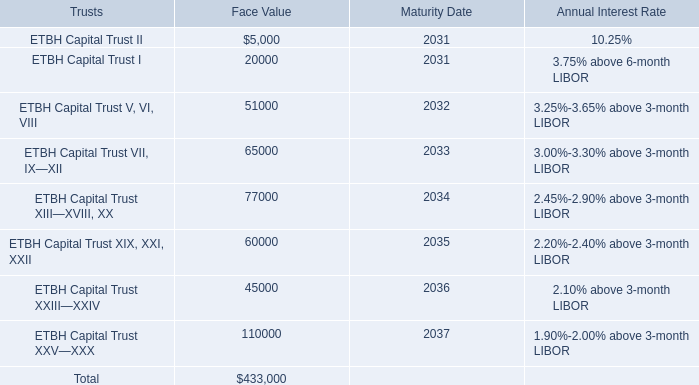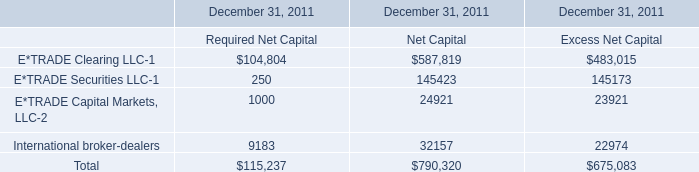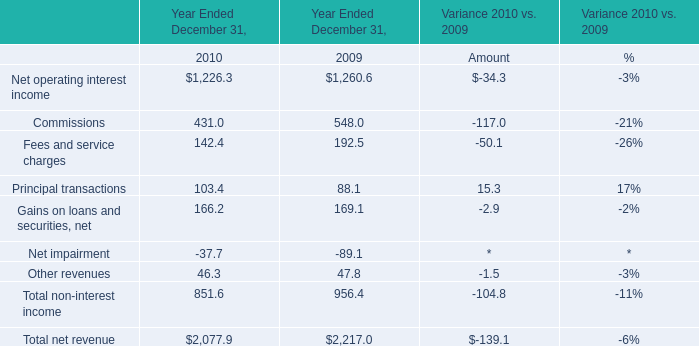What's the sum of ETBH Capital Trust XXIII—XXIV of Maturity Date, E*TRADE Clearing LLC of December 31, 2011 Required Net Capital, and Total of December 31, 2011 Net Capital ? 
Computations: ((2036.0 + 104804.0) + 790320.0)
Answer: 897160.0. 